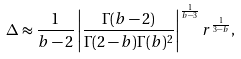Convert formula to latex. <formula><loc_0><loc_0><loc_500><loc_500>\Delta \approx \frac { 1 } { b - 2 } \left | \frac { \Gamma ( b - 2 ) } { \Gamma ( 2 - b ) \Gamma ( b ) ^ { 2 } } \right | ^ { \frac { 1 } { b - 3 } } r ^ { \frac { 1 } { 3 - b } } ,</formula> 